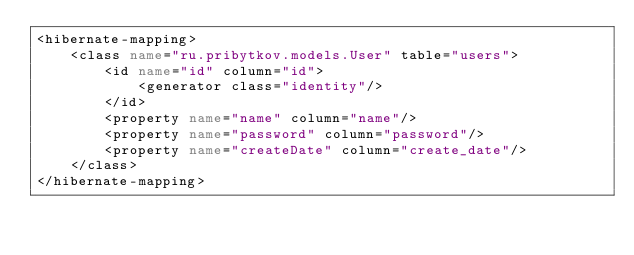Convert code to text. <code><loc_0><loc_0><loc_500><loc_500><_XML_><hibernate-mapping>
    <class name="ru.pribytkov.models.User" table="users">
        <id name="id" column="id">
            <generator class="identity"/>
        </id>
        <property name="name" column="name"/>
        <property name="password" column="password"/>
        <property name="createDate" column="create_date"/>
    </class>
</hibernate-mapping></code> 